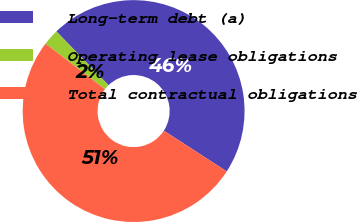Convert chart to OTSL. <chart><loc_0><loc_0><loc_500><loc_500><pie_chart><fcel>Long-term debt (a)<fcel>Operating lease obligations<fcel>Total contractual obligations<nl><fcel>46.41%<fcel>2.35%<fcel>51.24%<nl></chart> 